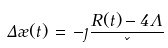Convert formula to latex. <formula><loc_0><loc_0><loc_500><loc_500>\Delta \rho ( t ) \, = \, - \eta \frac { R ( t ) - 4 \Lambda } { \kappa }</formula> 